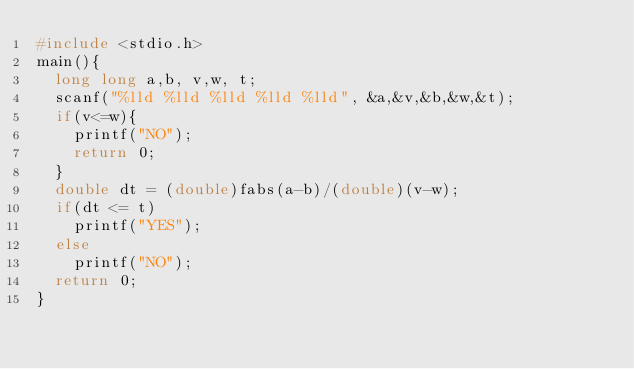<code> <loc_0><loc_0><loc_500><loc_500><_C_>#include <stdio.h>
main(){
  long long a,b, v,w, t;
  scanf("%lld %lld %lld %lld %lld", &a,&v,&b,&w,&t);
  if(v<=w){
    printf("NO");
    return 0;
  }
  double dt = (double)fabs(a-b)/(double)(v-w);
  if(dt <= t) 
    printf("YES");
  else
    printf("NO");
  return 0;
}</code> 